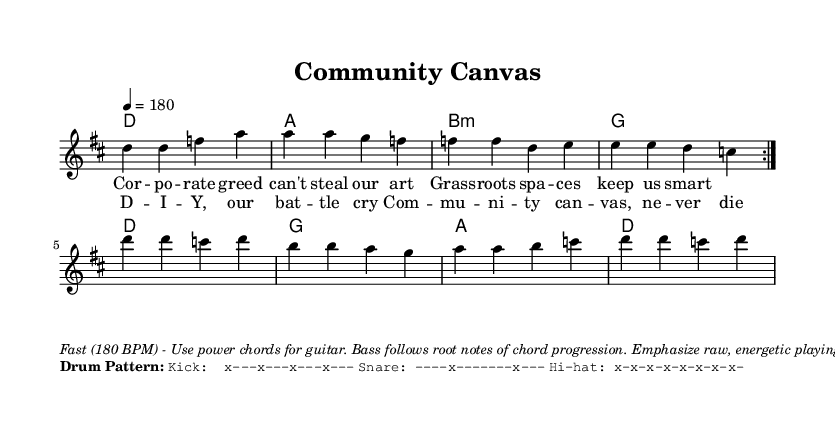What is the key signature of this music? The key signature is indicated by the "key" command in the global settings of the code, which specifies D major. D major has two sharps (F# and C#).
Answer: D major What is the time signature of this music? The time signature is outlined in the global section of the code and is written as "4/4". This means there are four beats in a measure and the quarter note receives one beat.
Answer: 4/4 What is the tempo marking of the piece? The tempo is specified in the global section with "4 = 180", indicating that the quarter note is played at 180 beats per minute.
Answer: 180 BPM What is the main lyrical theme of the song? The lyrics convey a message about grassroots art spaces resisting corporate influence. Phrases like "Corporate greed can't steal our art" suggest that the theme focuses on community and resilience against commercialization.
Answer: Community resistance How many times is the melody repeated in the verse section? The code specifies that the melody is repeated twice in the verse, as indicated by the "repeat volta 2" command. This means the melody will play through its section two times before moving on.
Answer: 2 times What instruments are implied for the arrangement in this music? The markup section provides instructions that suggest the arrangement includes guitar using power chords, a bass that follows root notes, and drums with a specific pattern. This is typical in punk music arrangements.
Answer: Guitar, bass, drums What is the drum pattern for the kick? The drum pattern written for the kick in the markup section shows a distinct pattern with kicks falling on the first beat of each measure. It is represented as "x---x---x---x---".
Answer: x---x---x---x--- 